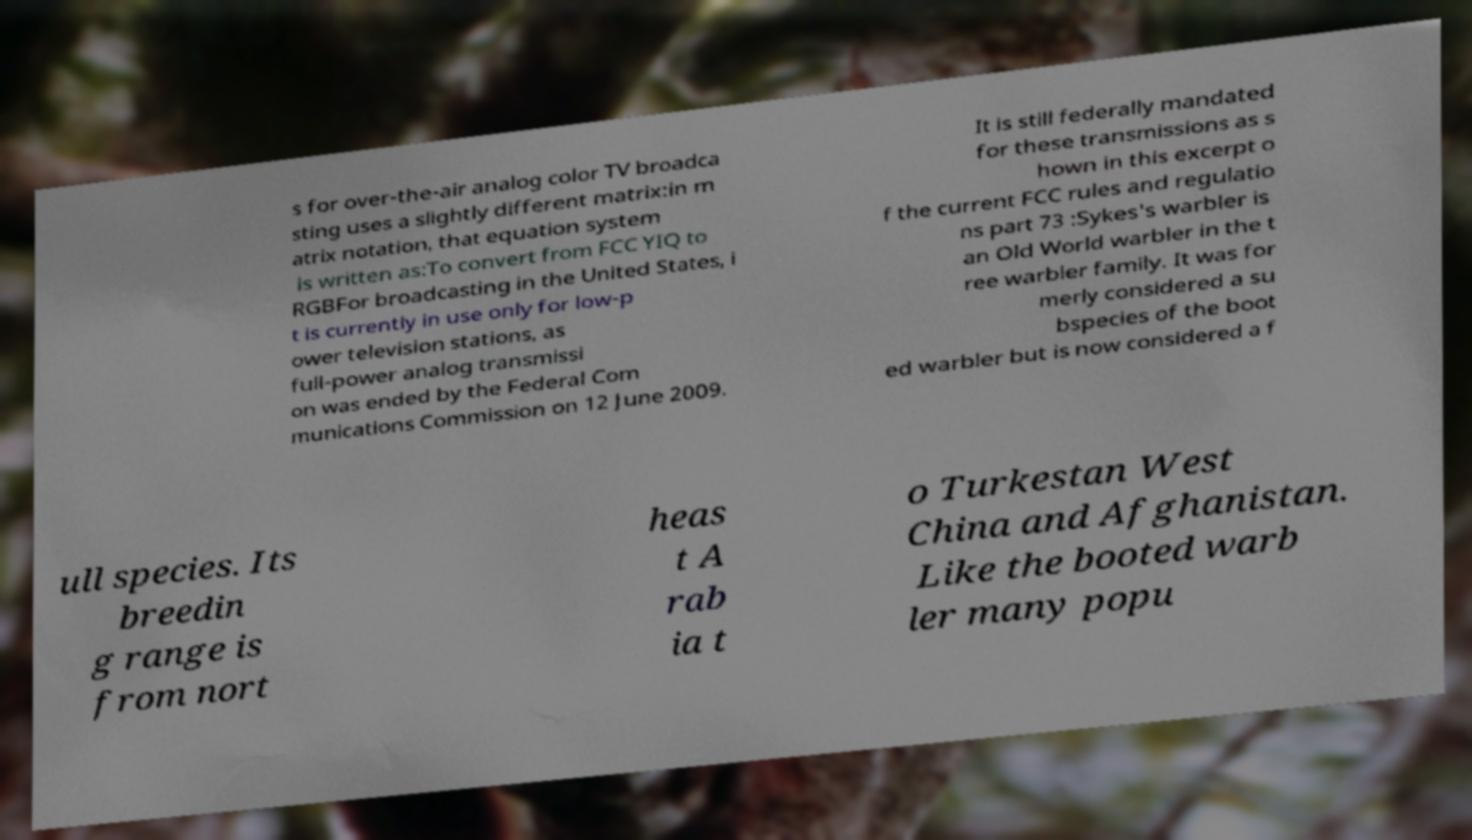There's text embedded in this image that I need extracted. Can you transcribe it verbatim? s for over-the-air analog color TV broadca sting uses a slightly different matrix:in m atrix notation, that equation system is written as:To convert from FCC YIQ to RGBFor broadcasting in the United States, i t is currently in use only for low-p ower television stations, as full-power analog transmissi on was ended by the Federal Com munications Commission on 12 June 2009. It is still federally mandated for these transmissions as s hown in this excerpt o f the current FCC rules and regulatio ns part 73 :Sykes's warbler is an Old World warbler in the t ree warbler family. It was for merly considered a su bspecies of the boot ed warbler but is now considered a f ull species. Its breedin g range is from nort heas t A rab ia t o Turkestan West China and Afghanistan. Like the booted warb ler many popu 